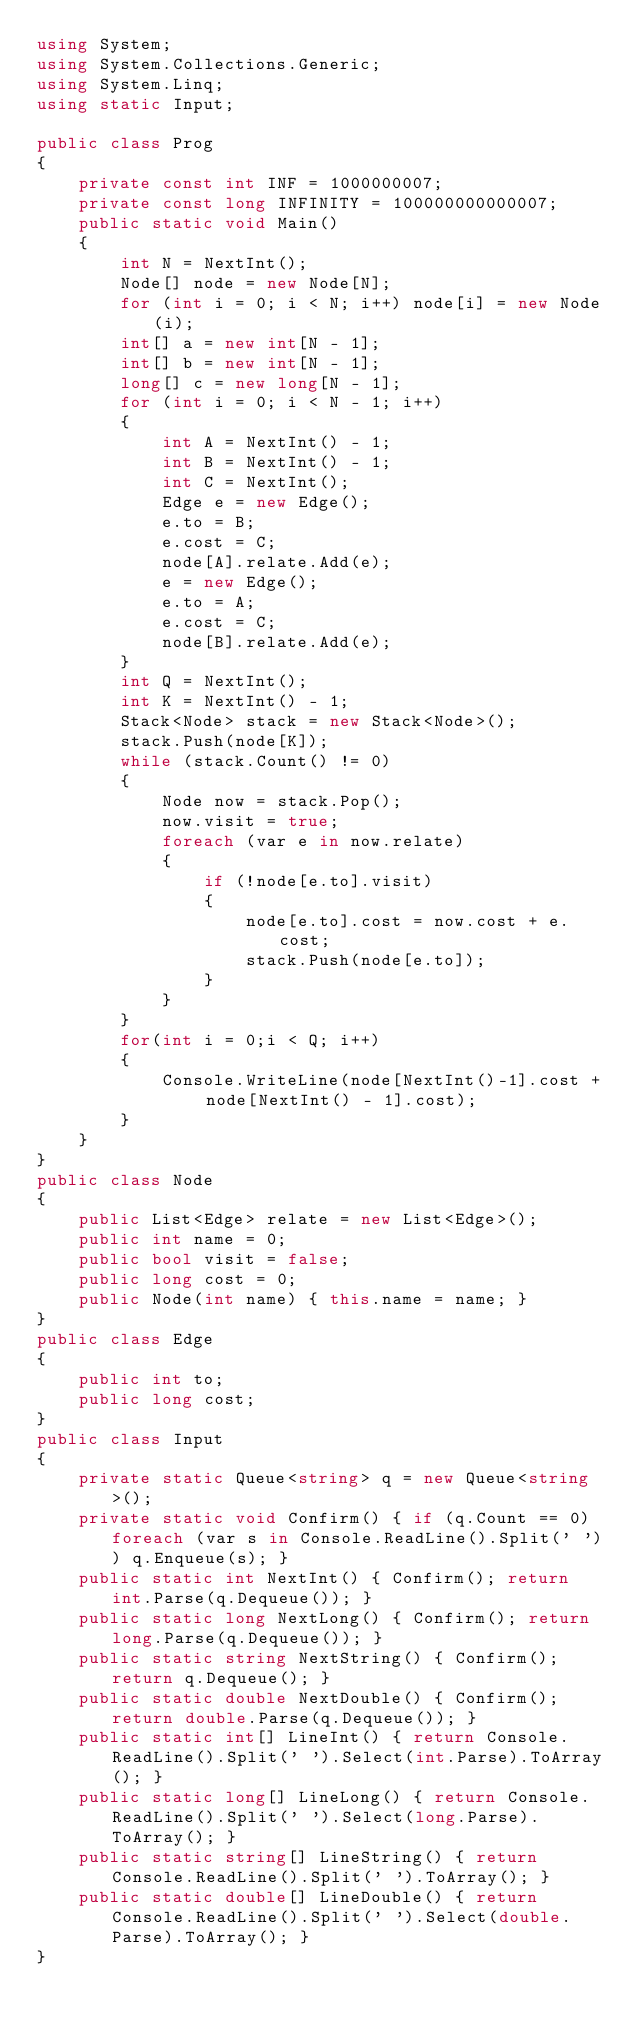Convert code to text. <code><loc_0><loc_0><loc_500><loc_500><_C#_>using System;
using System.Collections.Generic;
using System.Linq;
using static Input;

public class Prog
{
    private const int INF = 1000000007;
    private const long INFINITY = 100000000000007;
    public static void Main()
    {
        int N = NextInt();
        Node[] node = new Node[N];
        for (int i = 0; i < N; i++) node[i] = new Node(i);
        int[] a = new int[N - 1];
        int[] b = new int[N - 1];
        long[] c = new long[N - 1];
        for (int i = 0; i < N - 1; i++)
        {
            int A = NextInt() - 1;
            int B = NextInt() - 1;
            int C = NextInt();
            Edge e = new Edge();
            e.to = B;
            e.cost = C;
            node[A].relate.Add(e);
            e = new Edge();
            e.to = A;
            e.cost = C;
            node[B].relate.Add(e);
        }
        int Q = NextInt();
        int K = NextInt() - 1;
        Stack<Node> stack = new Stack<Node>();
        stack.Push(node[K]);
        while (stack.Count() != 0)
        {
            Node now = stack.Pop();
            now.visit = true;
            foreach (var e in now.relate)
            {
                if (!node[e.to].visit)
                {
                    node[e.to].cost = now.cost + e.cost;
                    stack.Push(node[e.to]);
                }
            }
        }
        for(int i = 0;i < Q; i++)
        {
            Console.WriteLine(node[NextInt()-1].cost + node[NextInt() - 1].cost);
        }
    }
}
public class Node
{
    public List<Edge> relate = new List<Edge>();
    public int name = 0;
    public bool visit = false;
    public long cost = 0;
    public Node(int name) { this.name = name; }
}
public class Edge
{
    public int to;
    public long cost;
}
public class Input
{
    private static Queue<string> q = new Queue<string>();
    private static void Confirm() { if (q.Count == 0) foreach (var s in Console.ReadLine().Split(' ')) q.Enqueue(s); }
    public static int NextInt() { Confirm(); return int.Parse(q.Dequeue()); }
    public static long NextLong() { Confirm(); return long.Parse(q.Dequeue()); }
    public static string NextString() { Confirm(); return q.Dequeue(); }
    public static double NextDouble() { Confirm(); return double.Parse(q.Dequeue()); }
    public static int[] LineInt() { return Console.ReadLine().Split(' ').Select(int.Parse).ToArray(); }
    public static long[] LineLong() { return Console.ReadLine().Split(' ').Select(long.Parse).ToArray(); }
    public static string[] LineString() { return Console.ReadLine().Split(' ').ToArray(); }
    public static double[] LineDouble() { return Console.ReadLine().Split(' ').Select(double.Parse).ToArray(); }
}</code> 